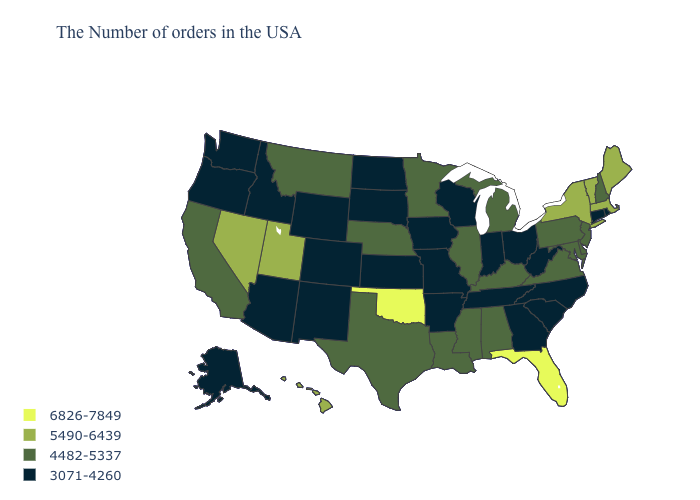What is the value of Kentucky?
Short answer required. 4482-5337. Which states have the lowest value in the USA?
Quick response, please. Rhode Island, Connecticut, North Carolina, South Carolina, West Virginia, Ohio, Georgia, Indiana, Tennessee, Wisconsin, Missouri, Arkansas, Iowa, Kansas, South Dakota, North Dakota, Wyoming, Colorado, New Mexico, Arizona, Idaho, Washington, Oregon, Alaska. What is the value of Oklahoma?
Answer briefly. 6826-7849. Name the states that have a value in the range 3071-4260?
Answer briefly. Rhode Island, Connecticut, North Carolina, South Carolina, West Virginia, Ohio, Georgia, Indiana, Tennessee, Wisconsin, Missouri, Arkansas, Iowa, Kansas, South Dakota, North Dakota, Wyoming, Colorado, New Mexico, Arizona, Idaho, Washington, Oregon, Alaska. Among the states that border Wisconsin , which have the highest value?
Quick response, please. Michigan, Illinois, Minnesota. How many symbols are there in the legend?
Answer briefly. 4. Does the first symbol in the legend represent the smallest category?
Quick response, please. No. Name the states that have a value in the range 3071-4260?
Be succinct. Rhode Island, Connecticut, North Carolina, South Carolina, West Virginia, Ohio, Georgia, Indiana, Tennessee, Wisconsin, Missouri, Arkansas, Iowa, Kansas, South Dakota, North Dakota, Wyoming, Colorado, New Mexico, Arizona, Idaho, Washington, Oregon, Alaska. What is the value of Minnesota?
Give a very brief answer. 4482-5337. What is the value of Massachusetts?
Concise answer only. 5490-6439. Does North Dakota have the lowest value in the USA?
Give a very brief answer. Yes. Does the map have missing data?
Quick response, please. No. Which states have the lowest value in the USA?
Quick response, please. Rhode Island, Connecticut, North Carolina, South Carolina, West Virginia, Ohio, Georgia, Indiana, Tennessee, Wisconsin, Missouri, Arkansas, Iowa, Kansas, South Dakota, North Dakota, Wyoming, Colorado, New Mexico, Arizona, Idaho, Washington, Oregon, Alaska. Name the states that have a value in the range 5490-6439?
Answer briefly. Maine, Massachusetts, Vermont, New York, Utah, Nevada, Hawaii. Which states have the highest value in the USA?
Be succinct. Florida, Oklahoma. 